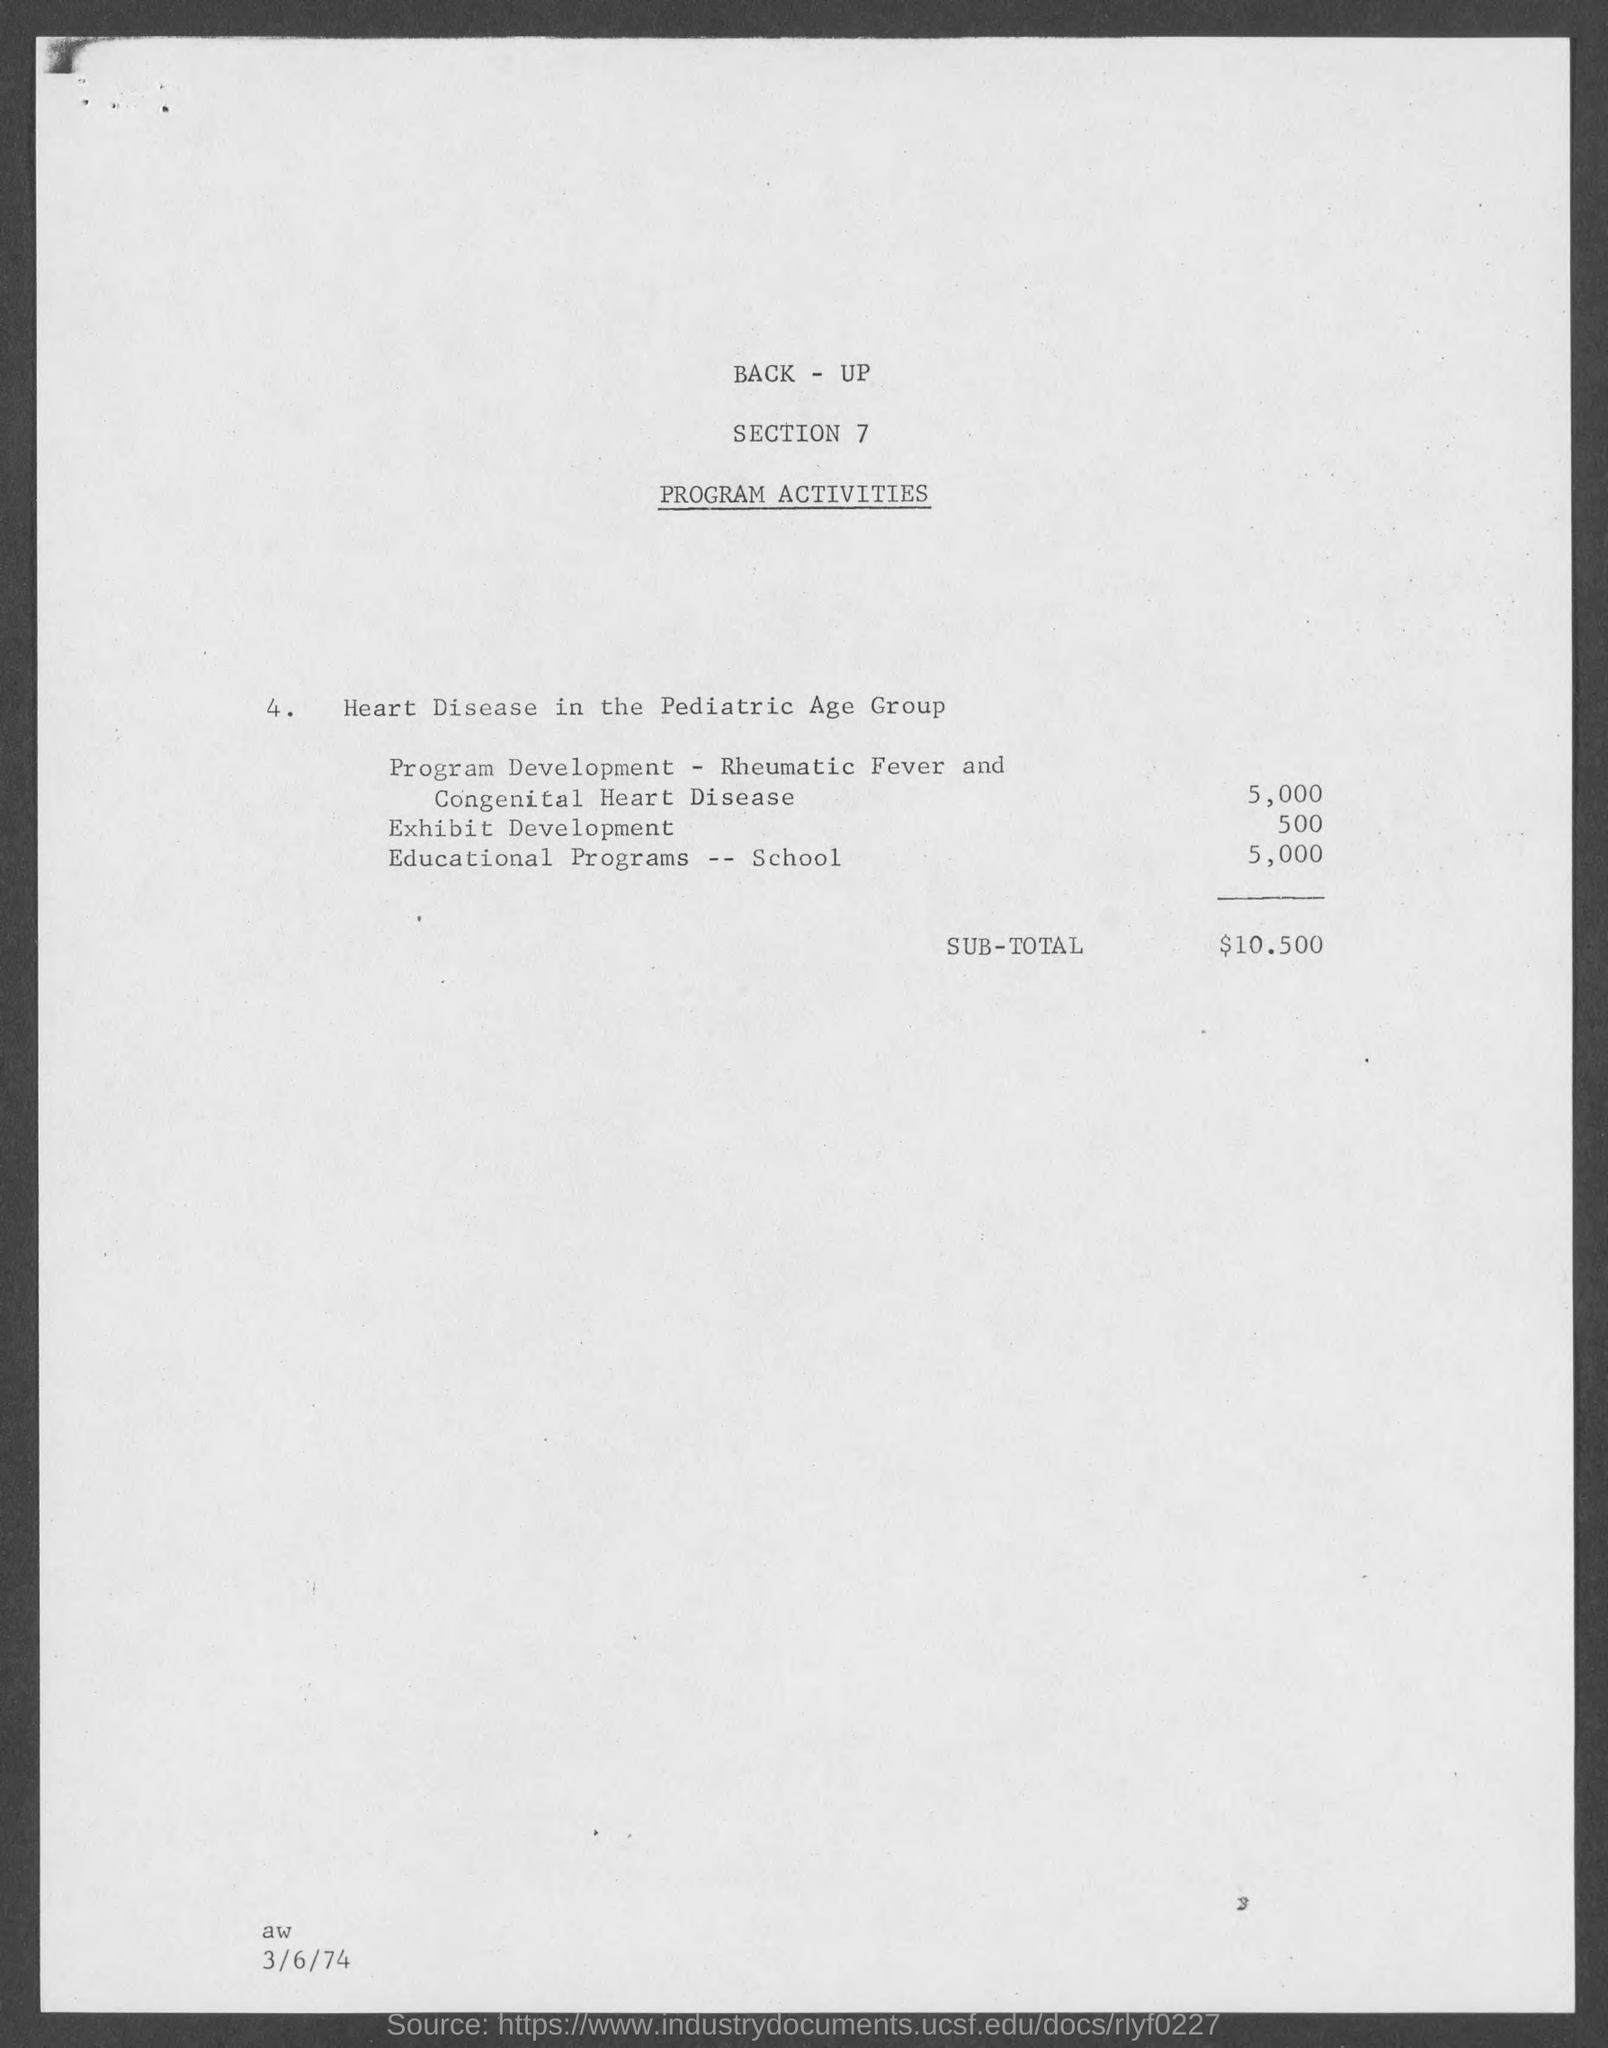Give some essential details in this illustration. The sub-total is $10,500. The cost for program development related to rheumatic fever and congenital heart disease is estimated to be 5,000. The cost for exhibit development is $500. The cost of educational programs for schools is $5,000. 